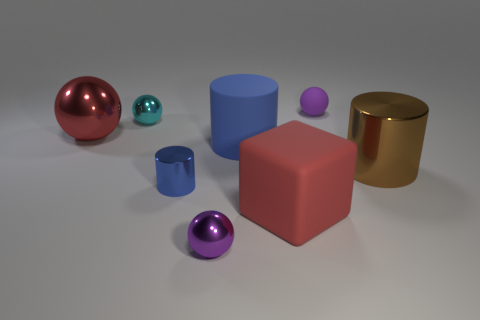Subtract all blue cylinders. How many were subtracted if there are1blue cylinders left? 1 Subtract 1 spheres. How many spheres are left? 3 Subtract all small spheres. How many spheres are left? 1 Add 1 red spheres. How many objects exist? 9 Subtract all yellow spheres. Subtract all yellow cubes. How many spheres are left? 4 Subtract all cylinders. How many objects are left? 5 Add 1 small metal objects. How many small metal objects are left? 4 Add 2 tiny brown shiny cylinders. How many tiny brown shiny cylinders exist? 2 Subtract 0 yellow cubes. How many objects are left? 8 Subtract all large gray metallic spheres. Subtract all big red matte blocks. How many objects are left? 7 